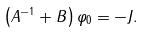<formula> <loc_0><loc_0><loc_500><loc_500>\left ( A ^ { - 1 } + B \right ) \varphi _ { 0 } = - J .</formula> 